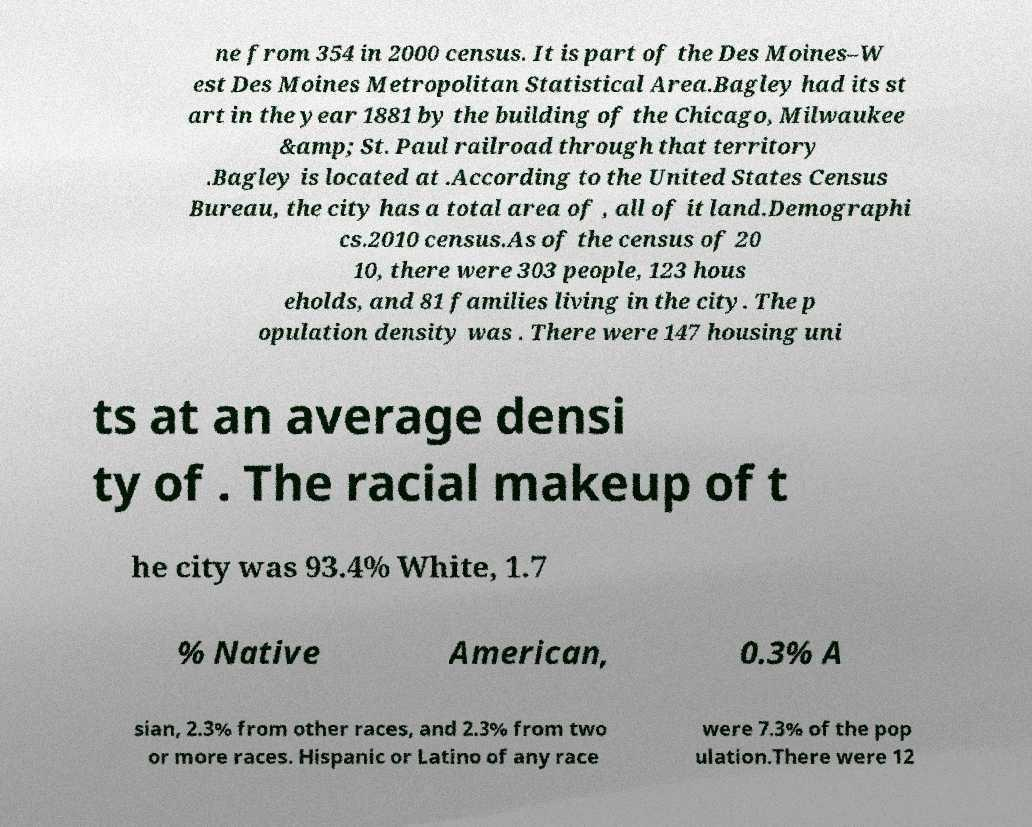Could you extract and type out the text from this image? ne from 354 in 2000 census. It is part of the Des Moines–W est Des Moines Metropolitan Statistical Area.Bagley had its st art in the year 1881 by the building of the Chicago, Milwaukee &amp; St. Paul railroad through that territory .Bagley is located at .According to the United States Census Bureau, the city has a total area of , all of it land.Demographi cs.2010 census.As of the census of 20 10, there were 303 people, 123 hous eholds, and 81 families living in the city. The p opulation density was . There were 147 housing uni ts at an average densi ty of . The racial makeup of t he city was 93.4% White, 1.7 % Native American, 0.3% A sian, 2.3% from other races, and 2.3% from two or more races. Hispanic or Latino of any race were 7.3% of the pop ulation.There were 12 